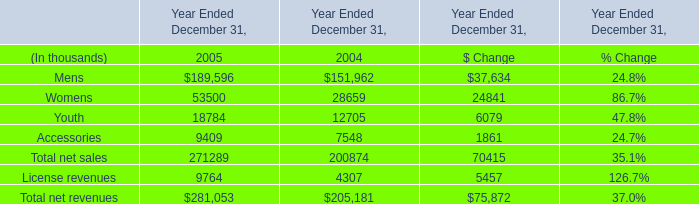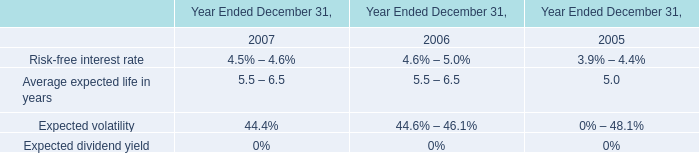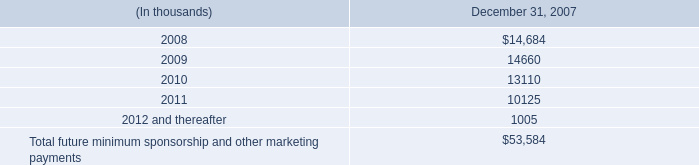in november 2005 what was the percent of the stock issue costs to the company proceeds 
Computations: (10.8 / 112.7)
Answer: 0.09583. 